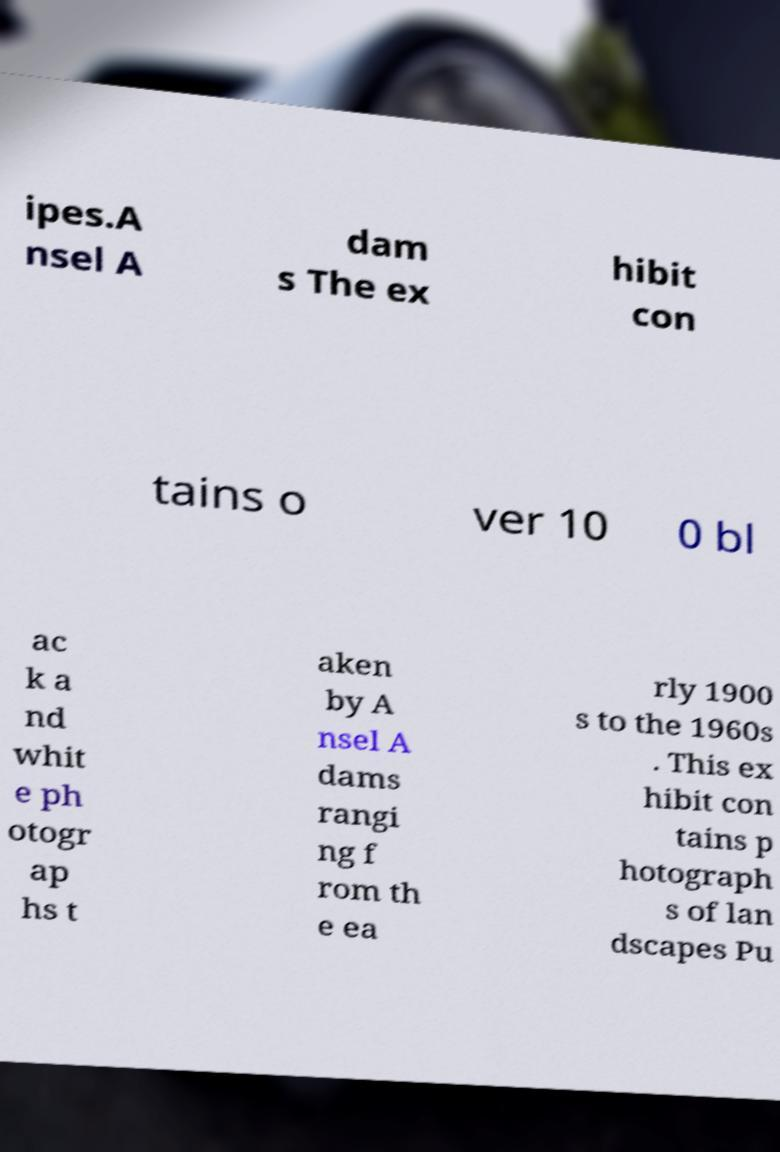Can you read and provide the text displayed in the image?This photo seems to have some interesting text. Can you extract and type it out for me? ipes.A nsel A dam s The ex hibit con tains o ver 10 0 bl ac k a nd whit e ph otogr ap hs t aken by A nsel A dams rangi ng f rom th e ea rly 1900 s to the 1960s . This ex hibit con tains p hotograph s of lan dscapes Pu 